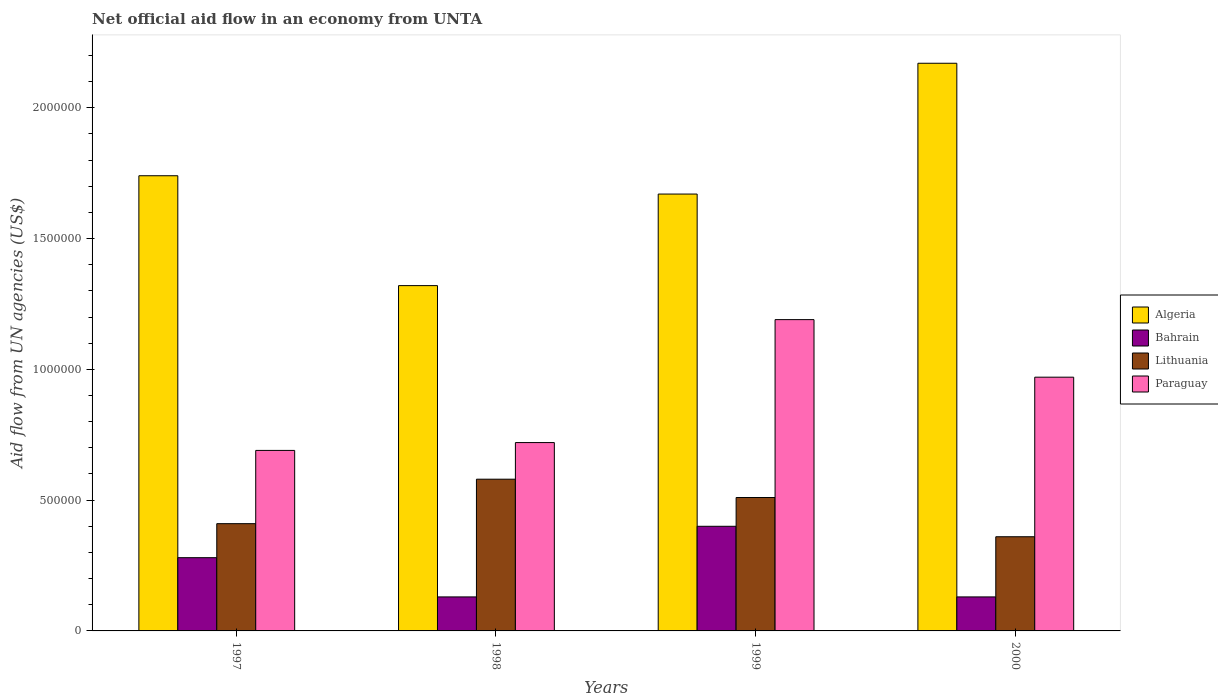In how many cases, is the number of bars for a given year not equal to the number of legend labels?
Provide a succinct answer. 0. What is the net official aid flow in Bahrain in 2000?
Keep it short and to the point. 1.30e+05. Across all years, what is the maximum net official aid flow in Bahrain?
Keep it short and to the point. 4.00e+05. In which year was the net official aid flow in Paraguay maximum?
Offer a terse response. 1999. In which year was the net official aid flow in Algeria minimum?
Give a very brief answer. 1998. What is the total net official aid flow in Lithuania in the graph?
Make the answer very short. 1.86e+06. What is the difference between the net official aid flow in Lithuania in 1998 and the net official aid flow in Algeria in 1997?
Your response must be concise. -1.16e+06. What is the average net official aid flow in Algeria per year?
Your answer should be compact. 1.72e+06. In the year 1997, what is the difference between the net official aid flow in Algeria and net official aid flow in Paraguay?
Provide a succinct answer. 1.05e+06. In how many years, is the net official aid flow in Lithuania greater than 300000 US$?
Your answer should be very brief. 4. What is the ratio of the net official aid flow in Bahrain in 1997 to that in 1999?
Offer a very short reply. 0.7. Is the net official aid flow in Paraguay in 1997 less than that in 1999?
Your response must be concise. Yes. Is the difference between the net official aid flow in Algeria in 1997 and 2000 greater than the difference between the net official aid flow in Paraguay in 1997 and 2000?
Give a very brief answer. No. In how many years, is the net official aid flow in Bahrain greater than the average net official aid flow in Bahrain taken over all years?
Your response must be concise. 2. Is it the case that in every year, the sum of the net official aid flow in Bahrain and net official aid flow in Algeria is greater than the sum of net official aid flow in Paraguay and net official aid flow in Lithuania?
Provide a short and direct response. No. What does the 2nd bar from the left in 1997 represents?
Provide a short and direct response. Bahrain. What does the 2nd bar from the right in 1997 represents?
Your answer should be compact. Lithuania. Is it the case that in every year, the sum of the net official aid flow in Algeria and net official aid flow in Lithuania is greater than the net official aid flow in Paraguay?
Keep it short and to the point. Yes. How many bars are there?
Give a very brief answer. 16. Are all the bars in the graph horizontal?
Provide a short and direct response. No. Are the values on the major ticks of Y-axis written in scientific E-notation?
Make the answer very short. No. Does the graph contain any zero values?
Ensure brevity in your answer.  No. Does the graph contain grids?
Make the answer very short. No. How many legend labels are there?
Offer a terse response. 4. How are the legend labels stacked?
Provide a short and direct response. Vertical. What is the title of the graph?
Offer a terse response. Net official aid flow in an economy from UNTA. Does "Kazakhstan" appear as one of the legend labels in the graph?
Offer a very short reply. No. What is the label or title of the X-axis?
Your answer should be compact. Years. What is the label or title of the Y-axis?
Provide a succinct answer. Aid flow from UN agencies (US$). What is the Aid flow from UN agencies (US$) of Algeria in 1997?
Offer a very short reply. 1.74e+06. What is the Aid flow from UN agencies (US$) in Bahrain in 1997?
Your response must be concise. 2.80e+05. What is the Aid flow from UN agencies (US$) in Lithuania in 1997?
Provide a succinct answer. 4.10e+05. What is the Aid flow from UN agencies (US$) in Paraguay in 1997?
Ensure brevity in your answer.  6.90e+05. What is the Aid flow from UN agencies (US$) in Algeria in 1998?
Give a very brief answer. 1.32e+06. What is the Aid flow from UN agencies (US$) in Lithuania in 1998?
Keep it short and to the point. 5.80e+05. What is the Aid flow from UN agencies (US$) of Paraguay in 1998?
Keep it short and to the point. 7.20e+05. What is the Aid flow from UN agencies (US$) in Algeria in 1999?
Make the answer very short. 1.67e+06. What is the Aid flow from UN agencies (US$) of Bahrain in 1999?
Ensure brevity in your answer.  4.00e+05. What is the Aid flow from UN agencies (US$) in Lithuania in 1999?
Ensure brevity in your answer.  5.10e+05. What is the Aid flow from UN agencies (US$) of Paraguay in 1999?
Your answer should be very brief. 1.19e+06. What is the Aid flow from UN agencies (US$) of Algeria in 2000?
Your answer should be compact. 2.17e+06. What is the Aid flow from UN agencies (US$) of Lithuania in 2000?
Make the answer very short. 3.60e+05. What is the Aid flow from UN agencies (US$) of Paraguay in 2000?
Make the answer very short. 9.70e+05. Across all years, what is the maximum Aid flow from UN agencies (US$) in Algeria?
Your response must be concise. 2.17e+06. Across all years, what is the maximum Aid flow from UN agencies (US$) of Lithuania?
Offer a terse response. 5.80e+05. Across all years, what is the maximum Aid flow from UN agencies (US$) in Paraguay?
Offer a terse response. 1.19e+06. Across all years, what is the minimum Aid flow from UN agencies (US$) of Algeria?
Your response must be concise. 1.32e+06. Across all years, what is the minimum Aid flow from UN agencies (US$) in Paraguay?
Make the answer very short. 6.90e+05. What is the total Aid flow from UN agencies (US$) in Algeria in the graph?
Offer a terse response. 6.90e+06. What is the total Aid flow from UN agencies (US$) of Bahrain in the graph?
Your answer should be very brief. 9.40e+05. What is the total Aid flow from UN agencies (US$) of Lithuania in the graph?
Your answer should be very brief. 1.86e+06. What is the total Aid flow from UN agencies (US$) in Paraguay in the graph?
Your answer should be very brief. 3.57e+06. What is the difference between the Aid flow from UN agencies (US$) in Lithuania in 1997 and that in 1998?
Offer a terse response. -1.70e+05. What is the difference between the Aid flow from UN agencies (US$) in Algeria in 1997 and that in 1999?
Provide a short and direct response. 7.00e+04. What is the difference between the Aid flow from UN agencies (US$) in Paraguay in 1997 and that in 1999?
Give a very brief answer. -5.00e+05. What is the difference between the Aid flow from UN agencies (US$) in Algeria in 1997 and that in 2000?
Your response must be concise. -4.30e+05. What is the difference between the Aid flow from UN agencies (US$) of Paraguay in 1997 and that in 2000?
Keep it short and to the point. -2.80e+05. What is the difference between the Aid flow from UN agencies (US$) in Algeria in 1998 and that in 1999?
Provide a short and direct response. -3.50e+05. What is the difference between the Aid flow from UN agencies (US$) of Bahrain in 1998 and that in 1999?
Offer a terse response. -2.70e+05. What is the difference between the Aid flow from UN agencies (US$) of Paraguay in 1998 and that in 1999?
Offer a terse response. -4.70e+05. What is the difference between the Aid flow from UN agencies (US$) in Algeria in 1998 and that in 2000?
Make the answer very short. -8.50e+05. What is the difference between the Aid flow from UN agencies (US$) of Lithuania in 1998 and that in 2000?
Give a very brief answer. 2.20e+05. What is the difference between the Aid flow from UN agencies (US$) in Algeria in 1999 and that in 2000?
Your response must be concise. -5.00e+05. What is the difference between the Aid flow from UN agencies (US$) of Lithuania in 1999 and that in 2000?
Your answer should be very brief. 1.50e+05. What is the difference between the Aid flow from UN agencies (US$) in Algeria in 1997 and the Aid flow from UN agencies (US$) in Bahrain in 1998?
Keep it short and to the point. 1.61e+06. What is the difference between the Aid flow from UN agencies (US$) in Algeria in 1997 and the Aid flow from UN agencies (US$) in Lithuania in 1998?
Make the answer very short. 1.16e+06. What is the difference between the Aid flow from UN agencies (US$) in Algeria in 1997 and the Aid flow from UN agencies (US$) in Paraguay in 1998?
Your answer should be compact. 1.02e+06. What is the difference between the Aid flow from UN agencies (US$) of Bahrain in 1997 and the Aid flow from UN agencies (US$) of Paraguay in 1998?
Provide a succinct answer. -4.40e+05. What is the difference between the Aid flow from UN agencies (US$) in Lithuania in 1997 and the Aid flow from UN agencies (US$) in Paraguay in 1998?
Your answer should be very brief. -3.10e+05. What is the difference between the Aid flow from UN agencies (US$) of Algeria in 1997 and the Aid flow from UN agencies (US$) of Bahrain in 1999?
Your answer should be very brief. 1.34e+06. What is the difference between the Aid flow from UN agencies (US$) in Algeria in 1997 and the Aid flow from UN agencies (US$) in Lithuania in 1999?
Provide a succinct answer. 1.23e+06. What is the difference between the Aid flow from UN agencies (US$) of Algeria in 1997 and the Aid flow from UN agencies (US$) of Paraguay in 1999?
Provide a short and direct response. 5.50e+05. What is the difference between the Aid flow from UN agencies (US$) in Bahrain in 1997 and the Aid flow from UN agencies (US$) in Lithuania in 1999?
Ensure brevity in your answer.  -2.30e+05. What is the difference between the Aid flow from UN agencies (US$) in Bahrain in 1997 and the Aid flow from UN agencies (US$) in Paraguay in 1999?
Make the answer very short. -9.10e+05. What is the difference between the Aid flow from UN agencies (US$) of Lithuania in 1997 and the Aid flow from UN agencies (US$) of Paraguay in 1999?
Keep it short and to the point. -7.80e+05. What is the difference between the Aid flow from UN agencies (US$) of Algeria in 1997 and the Aid flow from UN agencies (US$) of Bahrain in 2000?
Provide a succinct answer. 1.61e+06. What is the difference between the Aid flow from UN agencies (US$) of Algeria in 1997 and the Aid flow from UN agencies (US$) of Lithuania in 2000?
Give a very brief answer. 1.38e+06. What is the difference between the Aid flow from UN agencies (US$) in Algeria in 1997 and the Aid flow from UN agencies (US$) in Paraguay in 2000?
Provide a short and direct response. 7.70e+05. What is the difference between the Aid flow from UN agencies (US$) in Bahrain in 1997 and the Aid flow from UN agencies (US$) in Lithuania in 2000?
Your answer should be compact. -8.00e+04. What is the difference between the Aid flow from UN agencies (US$) in Bahrain in 1997 and the Aid flow from UN agencies (US$) in Paraguay in 2000?
Keep it short and to the point. -6.90e+05. What is the difference between the Aid flow from UN agencies (US$) in Lithuania in 1997 and the Aid flow from UN agencies (US$) in Paraguay in 2000?
Your answer should be compact. -5.60e+05. What is the difference between the Aid flow from UN agencies (US$) in Algeria in 1998 and the Aid flow from UN agencies (US$) in Bahrain in 1999?
Offer a very short reply. 9.20e+05. What is the difference between the Aid flow from UN agencies (US$) of Algeria in 1998 and the Aid flow from UN agencies (US$) of Lithuania in 1999?
Provide a short and direct response. 8.10e+05. What is the difference between the Aid flow from UN agencies (US$) in Bahrain in 1998 and the Aid flow from UN agencies (US$) in Lithuania in 1999?
Provide a short and direct response. -3.80e+05. What is the difference between the Aid flow from UN agencies (US$) in Bahrain in 1998 and the Aid flow from UN agencies (US$) in Paraguay in 1999?
Provide a short and direct response. -1.06e+06. What is the difference between the Aid flow from UN agencies (US$) of Lithuania in 1998 and the Aid flow from UN agencies (US$) of Paraguay in 1999?
Offer a very short reply. -6.10e+05. What is the difference between the Aid flow from UN agencies (US$) in Algeria in 1998 and the Aid flow from UN agencies (US$) in Bahrain in 2000?
Offer a terse response. 1.19e+06. What is the difference between the Aid flow from UN agencies (US$) of Algeria in 1998 and the Aid flow from UN agencies (US$) of Lithuania in 2000?
Your response must be concise. 9.60e+05. What is the difference between the Aid flow from UN agencies (US$) in Algeria in 1998 and the Aid flow from UN agencies (US$) in Paraguay in 2000?
Offer a terse response. 3.50e+05. What is the difference between the Aid flow from UN agencies (US$) in Bahrain in 1998 and the Aid flow from UN agencies (US$) in Lithuania in 2000?
Your answer should be very brief. -2.30e+05. What is the difference between the Aid flow from UN agencies (US$) in Bahrain in 1998 and the Aid flow from UN agencies (US$) in Paraguay in 2000?
Offer a very short reply. -8.40e+05. What is the difference between the Aid flow from UN agencies (US$) of Lithuania in 1998 and the Aid flow from UN agencies (US$) of Paraguay in 2000?
Offer a very short reply. -3.90e+05. What is the difference between the Aid flow from UN agencies (US$) in Algeria in 1999 and the Aid flow from UN agencies (US$) in Bahrain in 2000?
Your answer should be compact. 1.54e+06. What is the difference between the Aid flow from UN agencies (US$) of Algeria in 1999 and the Aid flow from UN agencies (US$) of Lithuania in 2000?
Provide a short and direct response. 1.31e+06. What is the difference between the Aid flow from UN agencies (US$) in Bahrain in 1999 and the Aid flow from UN agencies (US$) in Lithuania in 2000?
Offer a terse response. 4.00e+04. What is the difference between the Aid flow from UN agencies (US$) in Bahrain in 1999 and the Aid flow from UN agencies (US$) in Paraguay in 2000?
Your answer should be compact. -5.70e+05. What is the difference between the Aid flow from UN agencies (US$) in Lithuania in 1999 and the Aid flow from UN agencies (US$) in Paraguay in 2000?
Provide a succinct answer. -4.60e+05. What is the average Aid flow from UN agencies (US$) of Algeria per year?
Make the answer very short. 1.72e+06. What is the average Aid flow from UN agencies (US$) in Bahrain per year?
Ensure brevity in your answer.  2.35e+05. What is the average Aid flow from UN agencies (US$) in Lithuania per year?
Provide a short and direct response. 4.65e+05. What is the average Aid flow from UN agencies (US$) of Paraguay per year?
Your answer should be very brief. 8.92e+05. In the year 1997, what is the difference between the Aid flow from UN agencies (US$) of Algeria and Aid flow from UN agencies (US$) of Bahrain?
Offer a terse response. 1.46e+06. In the year 1997, what is the difference between the Aid flow from UN agencies (US$) of Algeria and Aid flow from UN agencies (US$) of Lithuania?
Offer a terse response. 1.33e+06. In the year 1997, what is the difference between the Aid flow from UN agencies (US$) of Algeria and Aid flow from UN agencies (US$) of Paraguay?
Your response must be concise. 1.05e+06. In the year 1997, what is the difference between the Aid flow from UN agencies (US$) in Bahrain and Aid flow from UN agencies (US$) in Paraguay?
Ensure brevity in your answer.  -4.10e+05. In the year 1997, what is the difference between the Aid flow from UN agencies (US$) in Lithuania and Aid flow from UN agencies (US$) in Paraguay?
Give a very brief answer. -2.80e+05. In the year 1998, what is the difference between the Aid flow from UN agencies (US$) in Algeria and Aid flow from UN agencies (US$) in Bahrain?
Your response must be concise. 1.19e+06. In the year 1998, what is the difference between the Aid flow from UN agencies (US$) of Algeria and Aid flow from UN agencies (US$) of Lithuania?
Give a very brief answer. 7.40e+05. In the year 1998, what is the difference between the Aid flow from UN agencies (US$) of Algeria and Aid flow from UN agencies (US$) of Paraguay?
Your answer should be very brief. 6.00e+05. In the year 1998, what is the difference between the Aid flow from UN agencies (US$) in Bahrain and Aid flow from UN agencies (US$) in Lithuania?
Offer a very short reply. -4.50e+05. In the year 1998, what is the difference between the Aid flow from UN agencies (US$) in Bahrain and Aid flow from UN agencies (US$) in Paraguay?
Make the answer very short. -5.90e+05. In the year 1998, what is the difference between the Aid flow from UN agencies (US$) of Lithuania and Aid flow from UN agencies (US$) of Paraguay?
Offer a terse response. -1.40e+05. In the year 1999, what is the difference between the Aid flow from UN agencies (US$) in Algeria and Aid flow from UN agencies (US$) in Bahrain?
Offer a terse response. 1.27e+06. In the year 1999, what is the difference between the Aid flow from UN agencies (US$) of Algeria and Aid flow from UN agencies (US$) of Lithuania?
Make the answer very short. 1.16e+06. In the year 1999, what is the difference between the Aid flow from UN agencies (US$) of Bahrain and Aid flow from UN agencies (US$) of Lithuania?
Offer a very short reply. -1.10e+05. In the year 1999, what is the difference between the Aid flow from UN agencies (US$) in Bahrain and Aid flow from UN agencies (US$) in Paraguay?
Provide a succinct answer. -7.90e+05. In the year 1999, what is the difference between the Aid flow from UN agencies (US$) of Lithuania and Aid flow from UN agencies (US$) of Paraguay?
Keep it short and to the point. -6.80e+05. In the year 2000, what is the difference between the Aid flow from UN agencies (US$) of Algeria and Aid flow from UN agencies (US$) of Bahrain?
Keep it short and to the point. 2.04e+06. In the year 2000, what is the difference between the Aid flow from UN agencies (US$) of Algeria and Aid flow from UN agencies (US$) of Lithuania?
Your answer should be very brief. 1.81e+06. In the year 2000, what is the difference between the Aid flow from UN agencies (US$) of Algeria and Aid flow from UN agencies (US$) of Paraguay?
Your response must be concise. 1.20e+06. In the year 2000, what is the difference between the Aid flow from UN agencies (US$) in Bahrain and Aid flow from UN agencies (US$) in Paraguay?
Provide a short and direct response. -8.40e+05. In the year 2000, what is the difference between the Aid flow from UN agencies (US$) of Lithuania and Aid flow from UN agencies (US$) of Paraguay?
Keep it short and to the point. -6.10e+05. What is the ratio of the Aid flow from UN agencies (US$) of Algeria in 1997 to that in 1998?
Your answer should be compact. 1.32. What is the ratio of the Aid flow from UN agencies (US$) of Bahrain in 1997 to that in 1998?
Offer a very short reply. 2.15. What is the ratio of the Aid flow from UN agencies (US$) of Lithuania in 1997 to that in 1998?
Ensure brevity in your answer.  0.71. What is the ratio of the Aid flow from UN agencies (US$) in Paraguay in 1997 to that in 1998?
Offer a terse response. 0.96. What is the ratio of the Aid flow from UN agencies (US$) in Algeria in 1997 to that in 1999?
Your response must be concise. 1.04. What is the ratio of the Aid flow from UN agencies (US$) in Lithuania in 1997 to that in 1999?
Your answer should be compact. 0.8. What is the ratio of the Aid flow from UN agencies (US$) of Paraguay in 1997 to that in 1999?
Provide a short and direct response. 0.58. What is the ratio of the Aid flow from UN agencies (US$) in Algeria in 1997 to that in 2000?
Provide a succinct answer. 0.8. What is the ratio of the Aid flow from UN agencies (US$) in Bahrain in 1997 to that in 2000?
Offer a terse response. 2.15. What is the ratio of the Aid flow from UN agencies (US$) of Lithuania in 1997 to that in 2000?
Your answer should be compact. 1.14. What is the ratio of the Aid flow from UN agencies (US$) in Paraguay in 1997 to that in 2000?
Your answer should be compact. 0.71. What is the ratio of the Aid flow from UN agencies (US$) of Algeria in 1998 to that in 1999?
Your answer should be very brief. 0.79. What is the ratio of the Aid flow from UN agencies (US$) in Bahrain in 1998 to that in 1999?
Offer a terse response. 0.33. What is the ratio of the Aid flow from UN agencies (US$) of Lithuania in 1998 to that in 1999?
Offer a very short reply. 1.14. What is the ratio of the Aid flow from UN agencies (US$) of Paraguay in 1998 to that in 1999?
Your answer should be compact. 0.6. What is the ratio of the Aid flow from UN agencies (US$) in Algeria in 1998 to that in 2000?
Make the answer very short. 0.61. What is the ratio of the Aid flow from UN agencies (US$) in Bahrain in 1998 to that in 2000?
Make the answer very short. 1. What is the ratio of the Aid flow from UN agencies (US$) of Lithuania in 1998 to that in 2000?
Your answer should be very brief. 1.61. What is the ratio of the Aid flow from UN agencies (US$) of Paraguay in 1998 to that in 2000?
Your answer should be very brief. 0.74. What is the ratio of the Aid flow from UN agencies (US$) in Algeria in 1999 to that in 2000?
Your response must be concise. 0.77. What is the ratio of the Aid flow from UN agencies (US$) of Bahrain in 1999 to that in 2000?
Your response must be concise. 3.08. What is the ratio of the Aid flow from UN agencies (US$) of Lithuania in 1999 to that in 2000?
Make the answer very short. 1.42. What is the ratio of the Aid flow from UN agencies (US$) of Paraguay in 1999 to that in 2000?
Give a very brief answer. 1.23. What is the difference between the highest and the second highest Aid flow from UN agencies (US$) of Bahrain?
Your answer should be very brief. 1.20e+05. What is the difference between the highest and the second highest Aid flow from UN agencies (US$) in Paraguay?
Your answer should be compact. 2.20e+05. What is the difference between the highest and the lowest Aid flow from UN agencies (US$) of Algeria?
Your response must be concise. 8.50e+05. What is the difference between the highest and the lowest Aid flow from UN agencies (US$) of Paraguay?
Provide a short and direct response. 5.00e+05. 